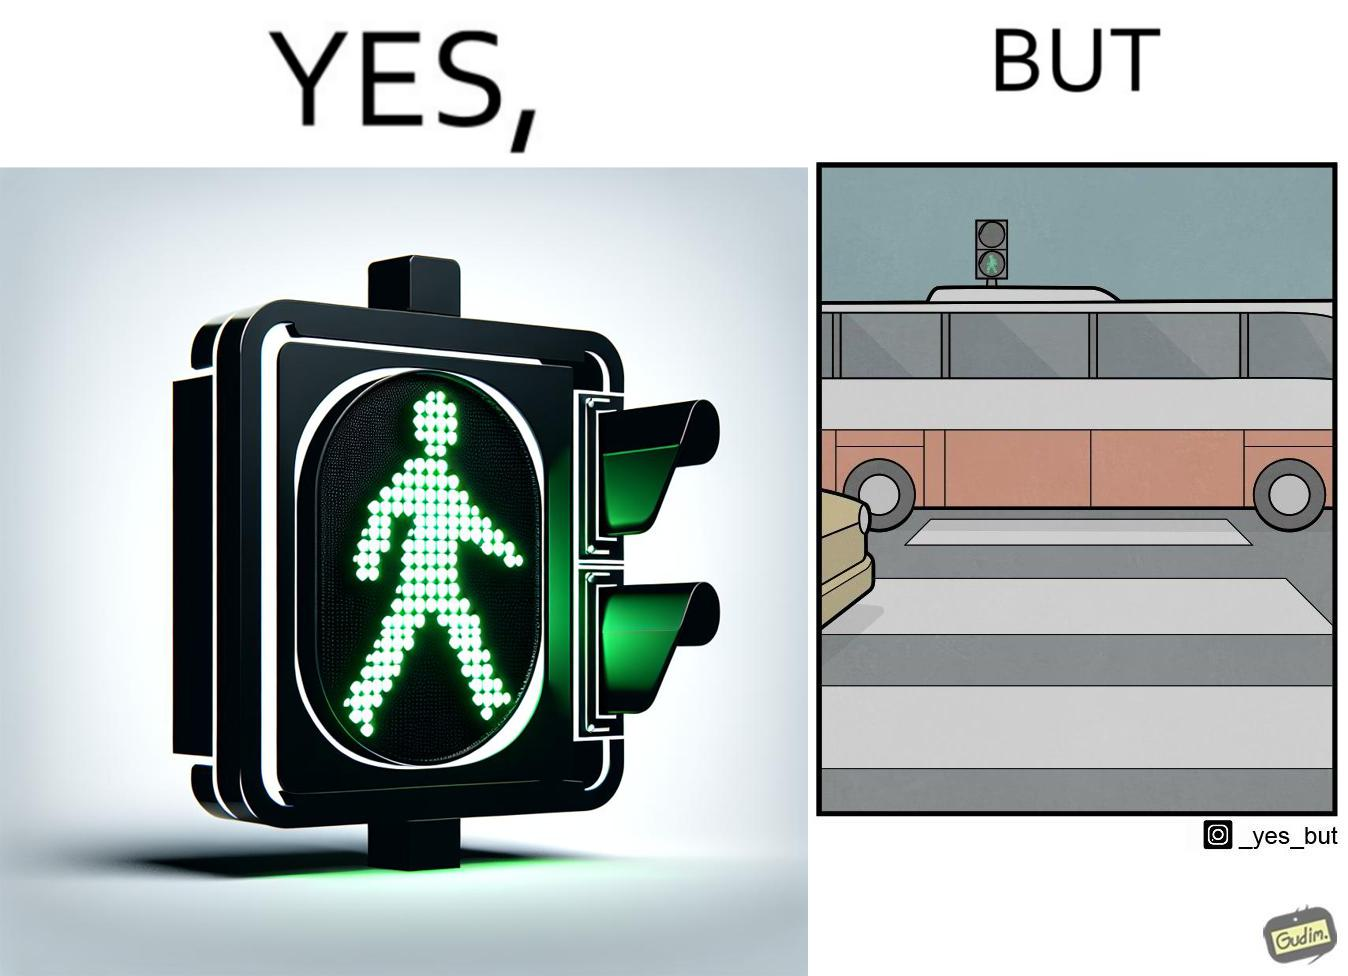What is shown in the left half versus the right half of this image? In the left part of the image: a traffic signal for the pedestrians and the signal is green, so pedestrians can cross the road In the right part of the image: a bus standing on the zebra crossing, while the traffic signal is green for the pedestrians symbolising  they can cross the road now 